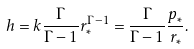Convert formula to latex. <formula><loc_0><loc_0><loc_500><loc_500>h = k \frac { \Gamma } { \Gamma - 1 } { r _ { * } ^ { \Gamma - 1 } } = \frac { \Gamma } { \Gamma - 1 } \frac { p _ { * } } { r _ { * } } .</formula> 